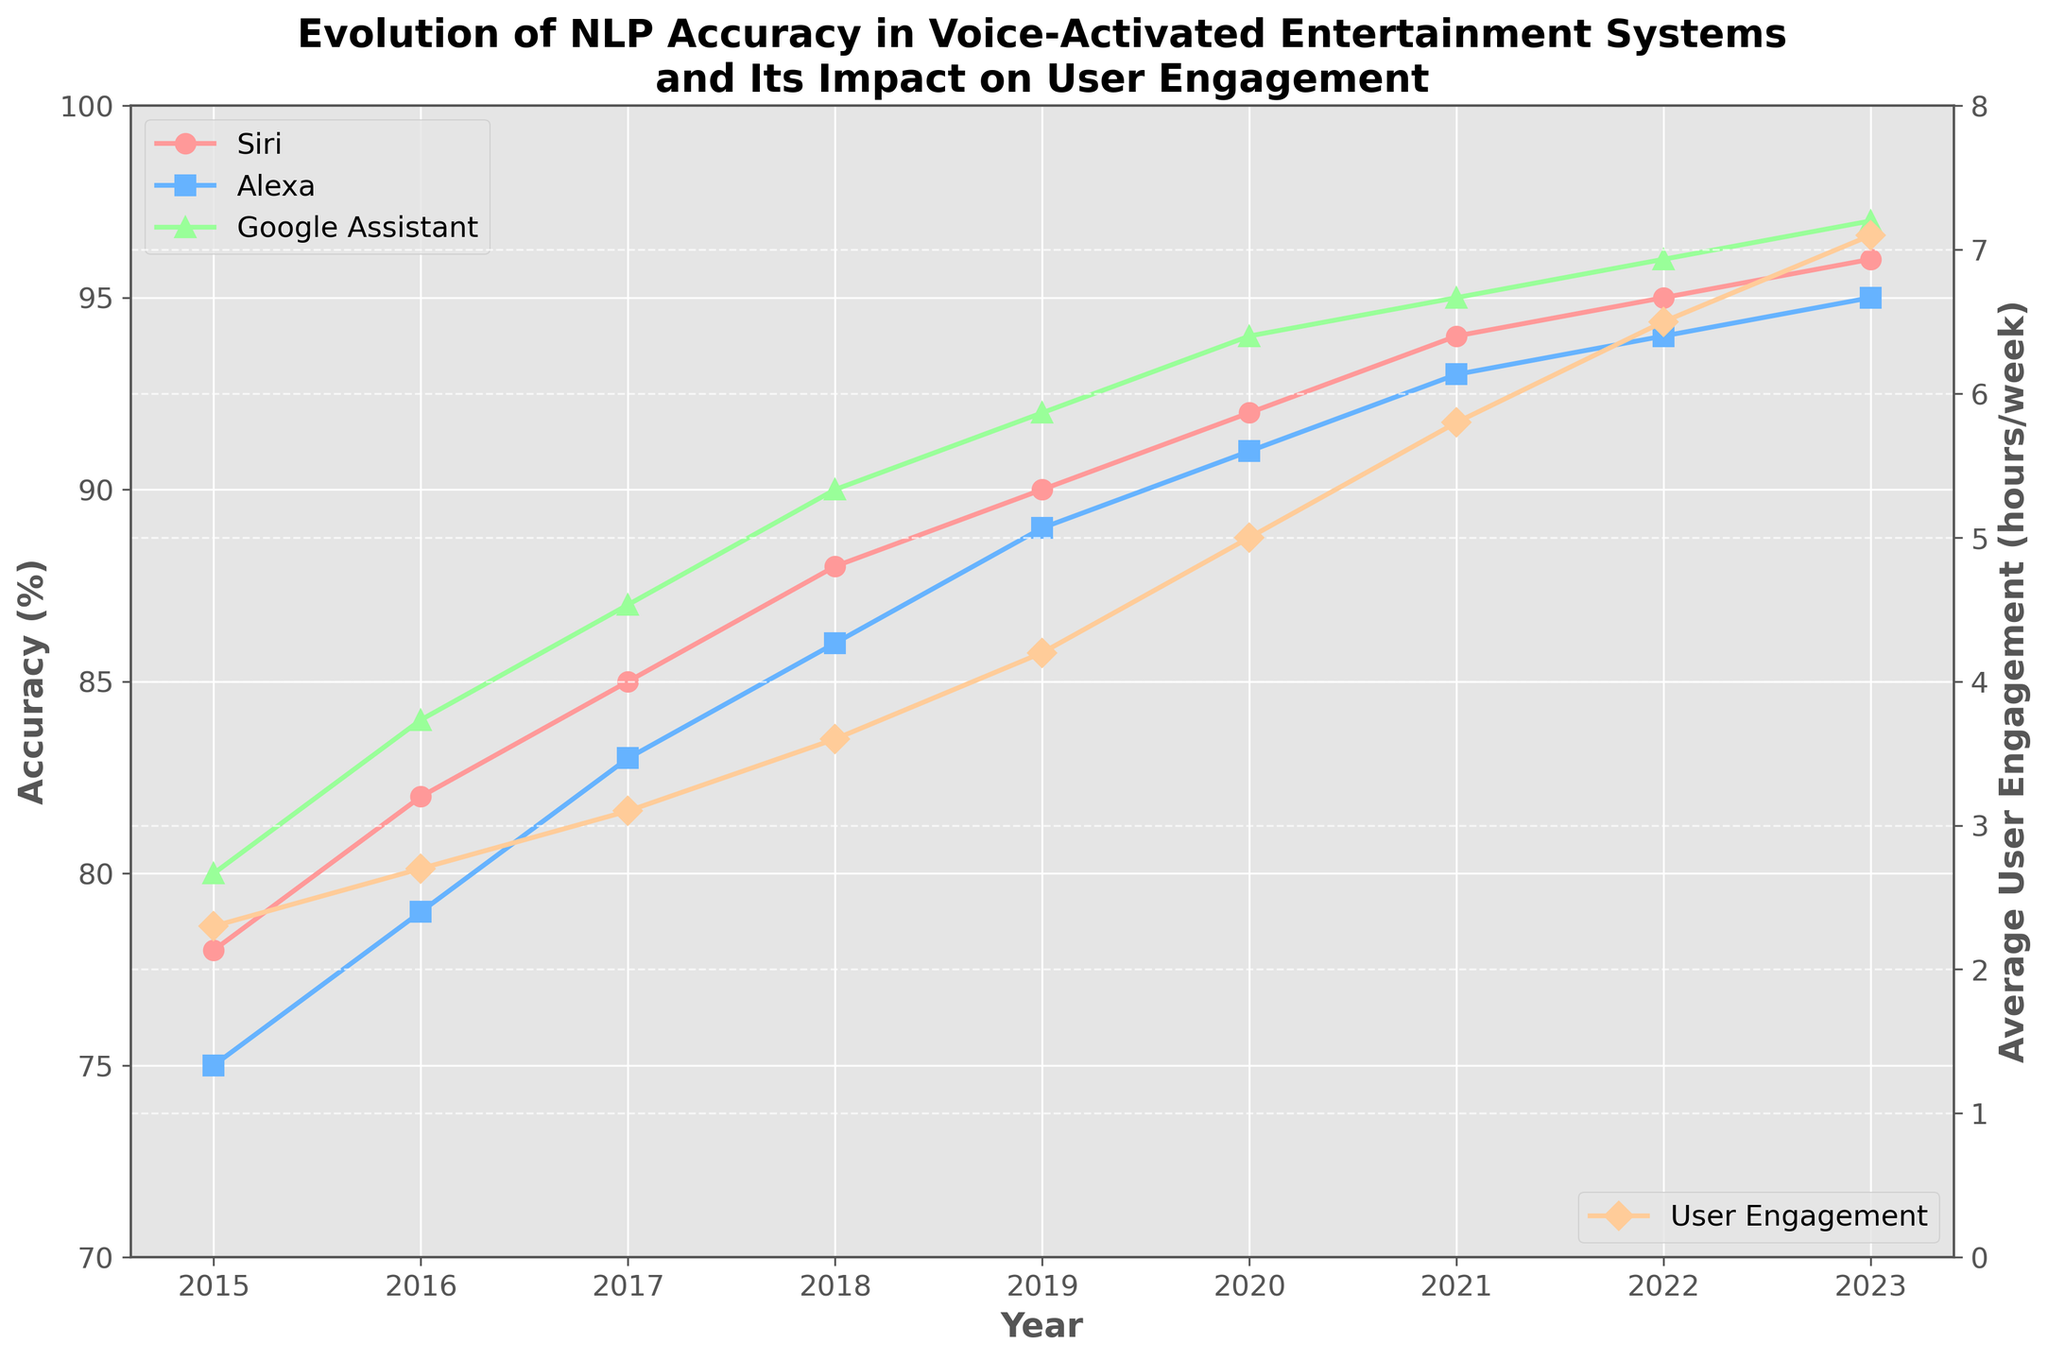What year did Google Assistant achieve an accuracy of 90% or higher? Look at the green line representing Google Assistant's accuracy and find when it first reaches 90%. It happens in 2018.
Answer: 2018 In which year did Siri surpass 90% accuracy? Look at the red line representing Siri's accuracy and find the first point where it crosses 90%. It is in 2019.
Answer: 2019 How much did average user engagement increase from 2015 to 2023? Subtract the value of user engagement in 2015 (2.3 hours/week) from that in 2023 (7.1 hours/week). The increase is 7.1 - 2.3 = 4.8 hours/week.
Answer: 4.8 hours/week Which virtual assistant had the highest accuracy in 2021? Compare the three lines (Siri in red, Alexa in blue, and Google Assistant in green) at the year 2021. Google Assistant has the highest accuracy with 95%.
Answer: Google Assistant How many years did it take for Alexa to reach 90% accuracy from 2015? Find the first year where Alexa’s accuracy (blue line) reaches 90%, which is in 2020. Then, subtract 2015 from 2020, giving 2020 - 2015 = 5 years.
Answer: 5 years Which year had the greatest year-over-year increase in user engagement? Look at the yellow line and calculate year-over-year changes: 2.7-2.3=0.4 (2016), 3.1-2.7=0.4 (2017), 3.6-3.1=0.5 (2018), 4.2-3.6=0.6 (2019), 5.0-4.2=0.8 (2020), 5.8-5.0=0.8 (2021), 6.5-5.8=0.7 (2022), 7.1-6.5=0.6 (2023). The greatest increase is 0.8 hours in 2020 and 2021.
Answer: 2020 and 2021 Between which consecutive years did Google Assistant's accuracy see the smallest increase? Calculate year-over-year changes for Google Assistant: 84-80=4 (2016-2015), 87-84=3 (2017-2016), 90-87=3 (2018-2017), 92-90=2 (2019-2018), 94-92=2 (2020-2019), 95-94=1 (2021-2020), 96-95=1 (2022-2021), 97-96=1 (2023-2022). The smallest increase of 1% occurred between 2020-2021, 2021-2022, and 2022-2023.
Answer: 2020-2021, 2021-2022, 2022-2023 What is the average accuracy of Siri from 2018 to 2023? Sum up Siri's accuracy from 2018 to 2023: 88+90+92+94+95+96=555. Divide by the number of years, 555/6 = 92.5%.
Answer: 92.5% Compare the accuracy trends of Siri and Alexa over the years. Did Alexa ever surpass Siri? Examine the red and blue lines over the plotted years. The lines never cross; Siri's line (red) is always above or equal to Alexa's line (blue).
Answer: No What is the difference in user engagement between 2017 and 2020? Subtract the user engagement in 2017 (3.1 hours/week) from that in 2020 (5.0 hours/week): 5.0 - 3.1 = 1.9 hours/week.
Answer: 1.9 hours/week 